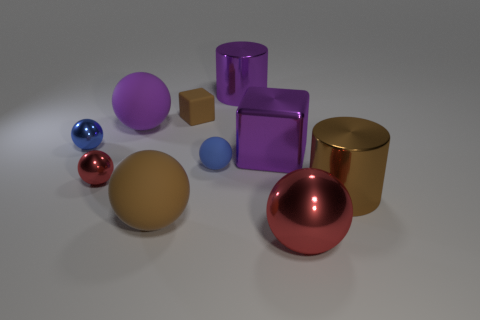Does the shadowing give us any clues about the light source? Yes, the shadows fall mainly to the right and slightly forward of the objects, indicating the light source is to the left and somewhat above the scene. 